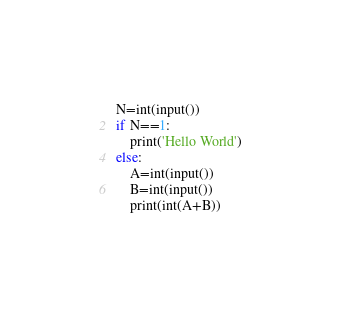<code> <loc_0><loc_0><loc_500><loc_500><_Python_>N=int(input())
if N==1:
    print('Hello World')
else:
    A=int(input())
    B=int(input())
    print(int(A+B))</code> 